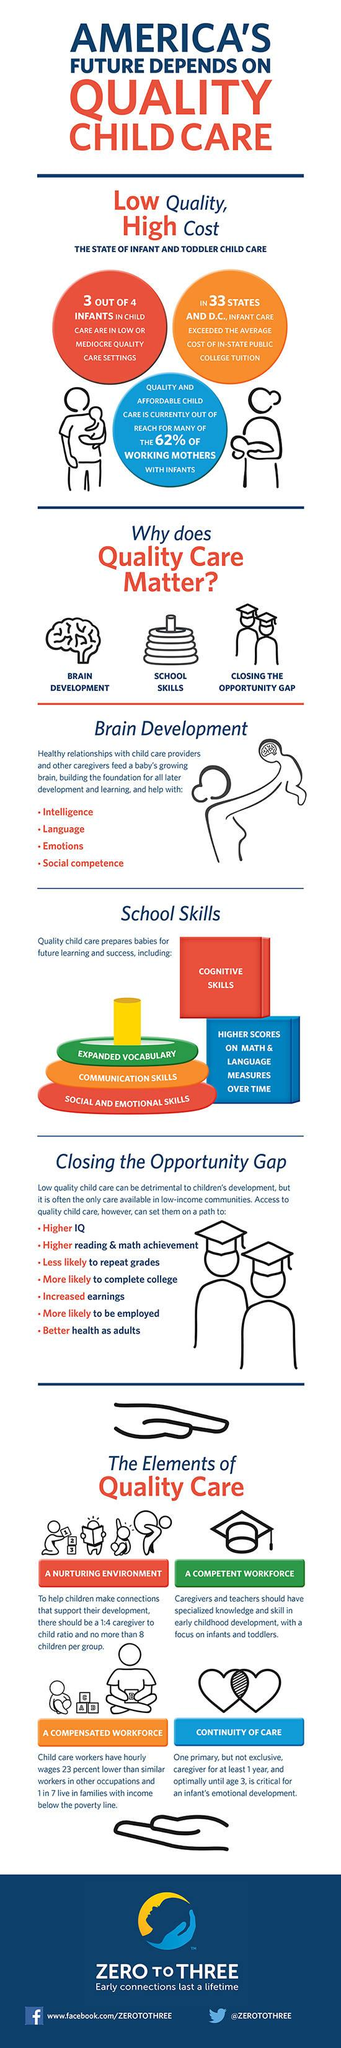Mention a couple of crucial points in this snapshot. The Twitter handle mentioned is "@ZEROTOTHREE. It is crucial to provide quality care to children in order to support their brain development, enhance their school skills, and address the opportunity gap. 